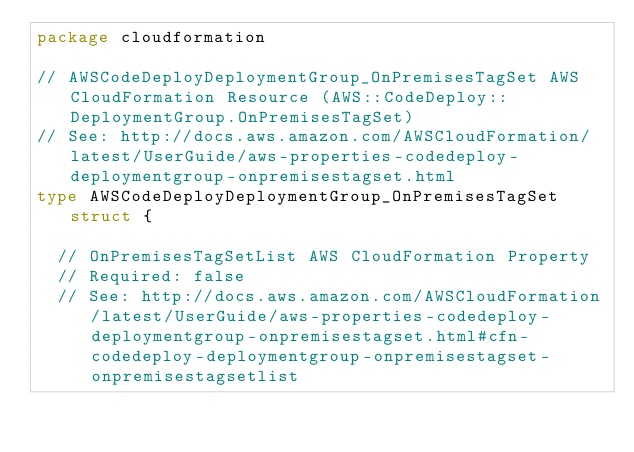Convert code to text. <code><loc_0><loc_0><loc_500><loc_500><_Go_>package cloudformation

// AWSCodeDeployDeploymentGroup_OnPremisesTagSet AWS CloudFormation Resource (AWS::CodeDeploy::DeploymentGroup.OnPremisesTagSet)
// See: http://docs.aws.amazon.com/AWSCloudFormation/latest/UserGuide/aws-properties-codedeploy-deploymentgroup-onpremisestagset.html
type AWSCodeDeployDeploymentGroup_OnPremisesTagSet struct {

	// OnPremisesTagSetList AWS CloudFormation Property
	// Required: false
	// See: http://docs.aws.amazon.com/AWSCloudFormation/latest/UserGuide/aws-properties-codedeploy-deploymentgroup-onpremisestagset.html#cfn-codedeploy-deploymentgroup-onpremisestagset-onpremisestagsetlist</code> 